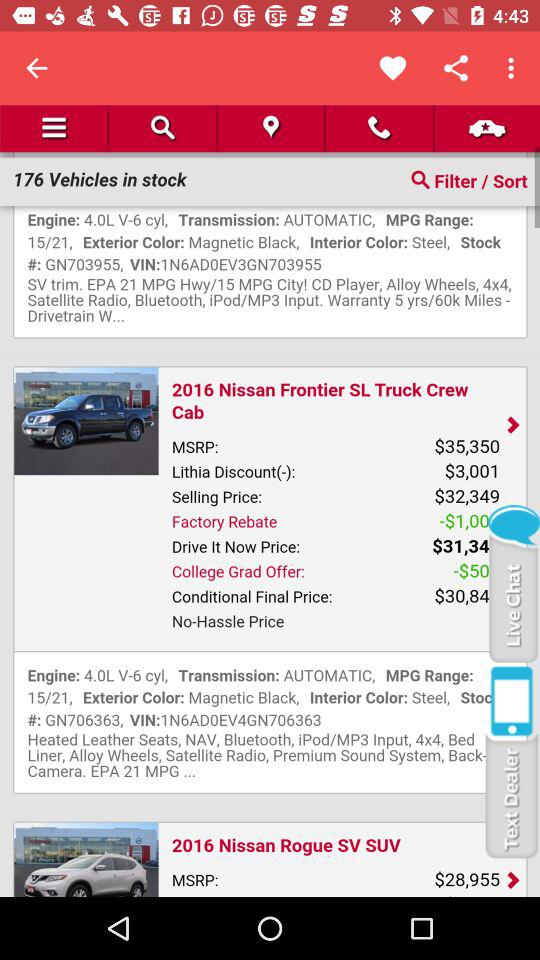What is the VIN number of "2016 Nissan Frontier SL Truck Crew Cab"? The VIN number is 1N6AD0EV4GN706363. 